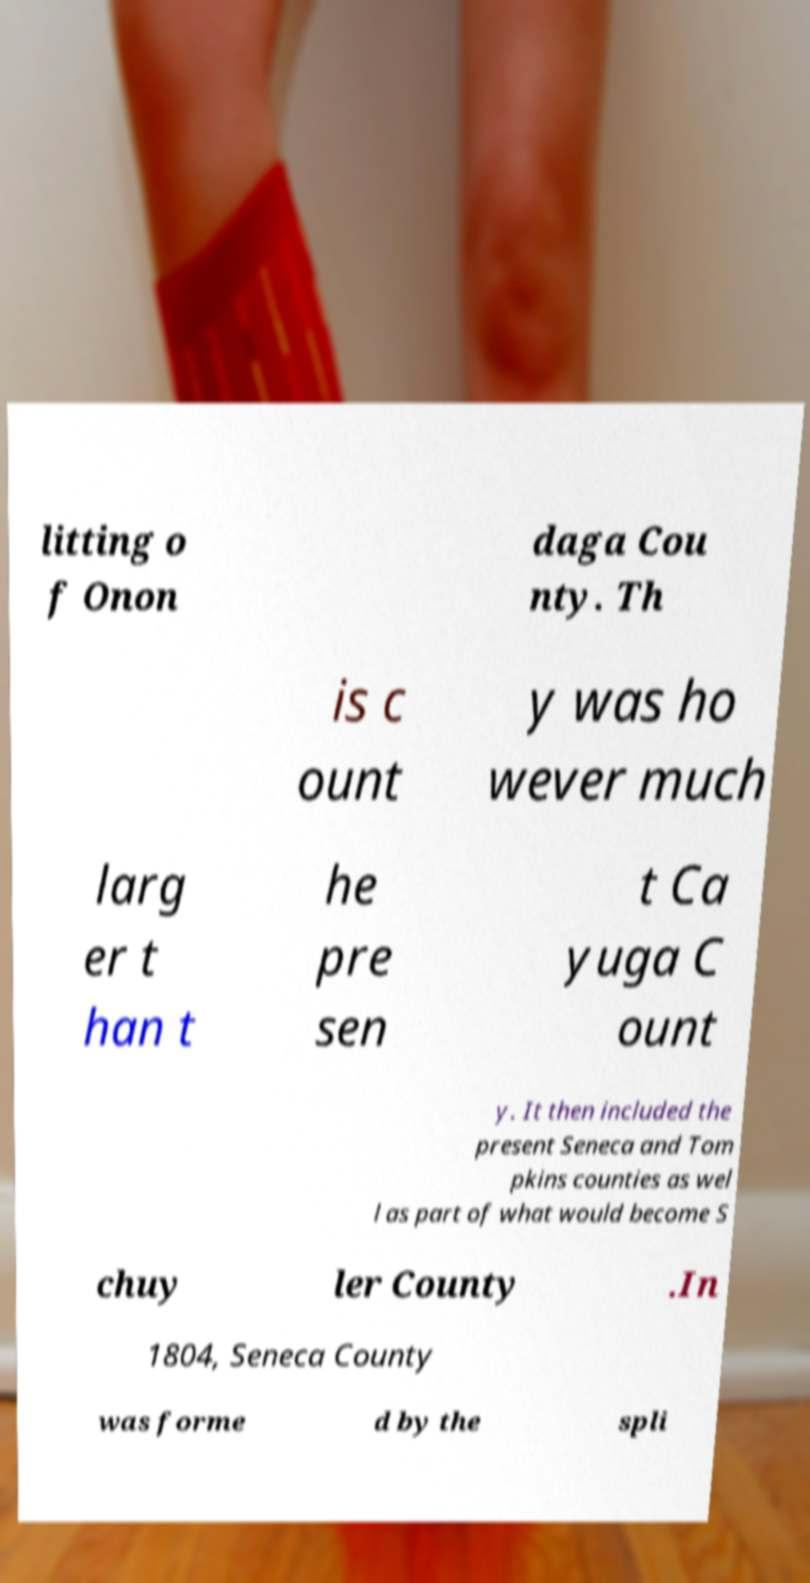What messages or text are displayed in this image? I need them in a readable, typed format. litting o f Onon daga Cou nty. Th is c ount y was ho wever much larg er t han t he pre sen t Ca yuga C ount y. It then included the present Seneca and Tom pkins counties as wel l as part of what would become S chuy ler County .In 1804, Seneca County was forme d by the spli 